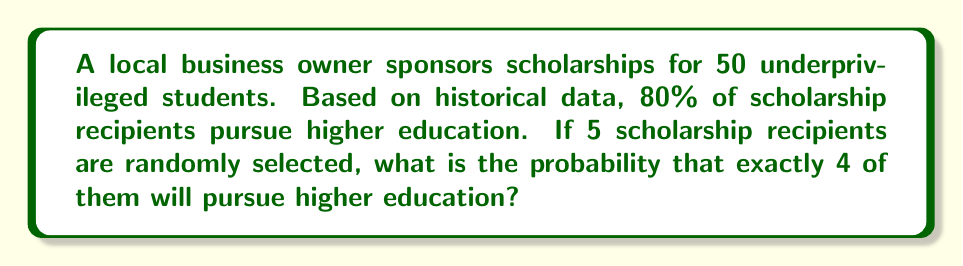Could you help me with this problem? To solve this problem, we'll use the binomial probability formula:

$$ P(X = k) = \binom{n}{k} p^k (1-p)^{n-k} $$

Where:
- $n$ is the number of trials (selected students)
- $k$ is the number of successes (students pursuing higher education)
- $p$ is the probability of success on each trial

Given:
- $n = 5$ (randomly selected students)
- $k = 4$ (exactly 4 pursuing higher education)
- $p = 0.80$ (80% probability of pursuing higher education)

Step 1: Calculate the binomial coefficient
$$ \binom{5}{4} = \frac{5!}{4!(5-4)!} = \frac{5!}{4!1!} = 5 $$

Step 2: Substitute values into the binomial probability formula
$$ P(X = 4) = \binom{5}{4} (0.80)^4 (1-0.80)^{5-4} $$
$$ P(X = 4) = 5 \cdot (0.80)^4 \cdot (0.20)^1 $$

Step 3: Calculate the probability
$$ P(X = 4) = 5 \cdot 0.4096 \cdot 0.20 $$
$$ P(X = 4) = 0.4096 $$

Therefore, the probability that exactly 4 out of 5 randomly selected scholarship recipients will pursue higher education is approximately 0.4096 or 40.96%.
Answer: 0.4096 